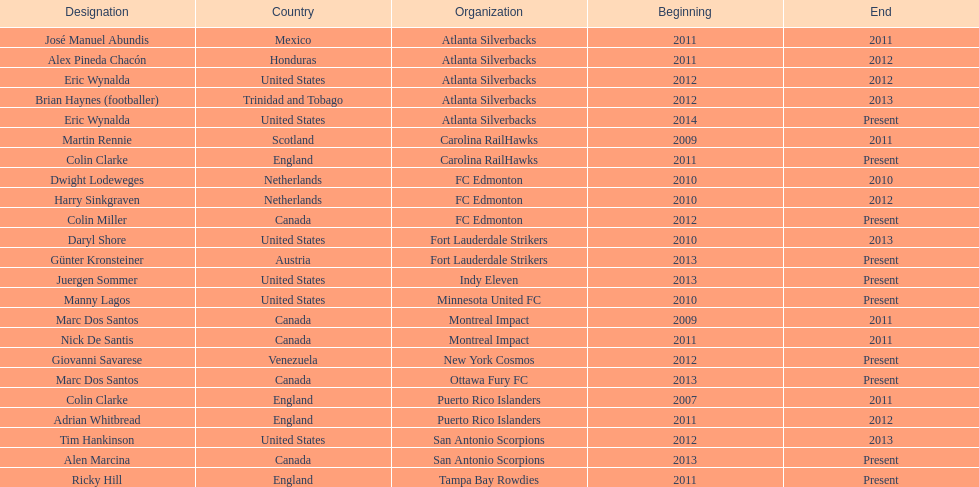Marc dos santos started as coach the same year as what other coach? Martin Rennie. 